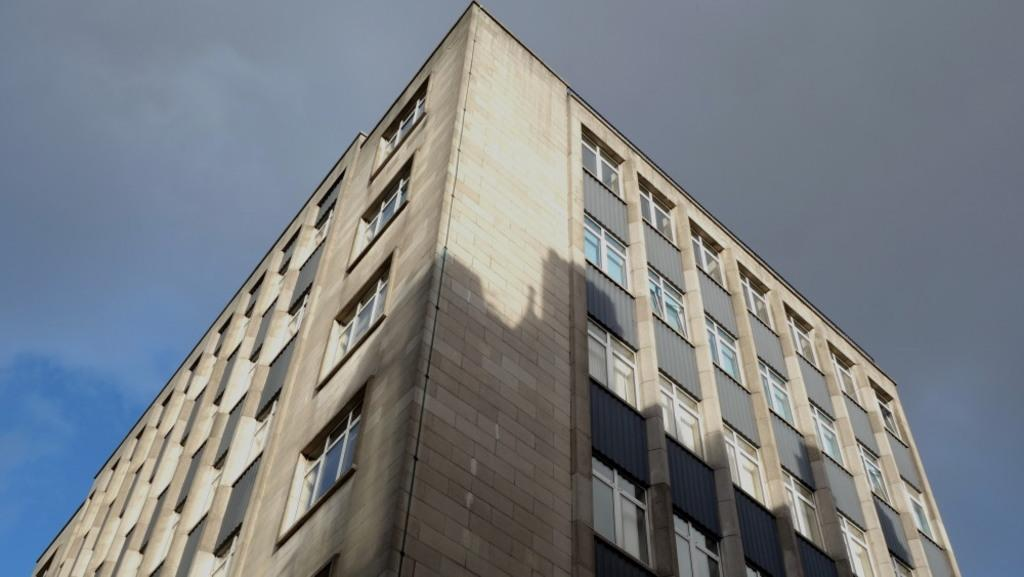What is the main subject of the image? The main subject of the image is a building. What specific features can be observed on the building? The building has windows. What can be seen in the background of the image? The sky is visible in the background of the image. How many dinosaurs can be seen in the image? There are no dinosaurs present in the image. 